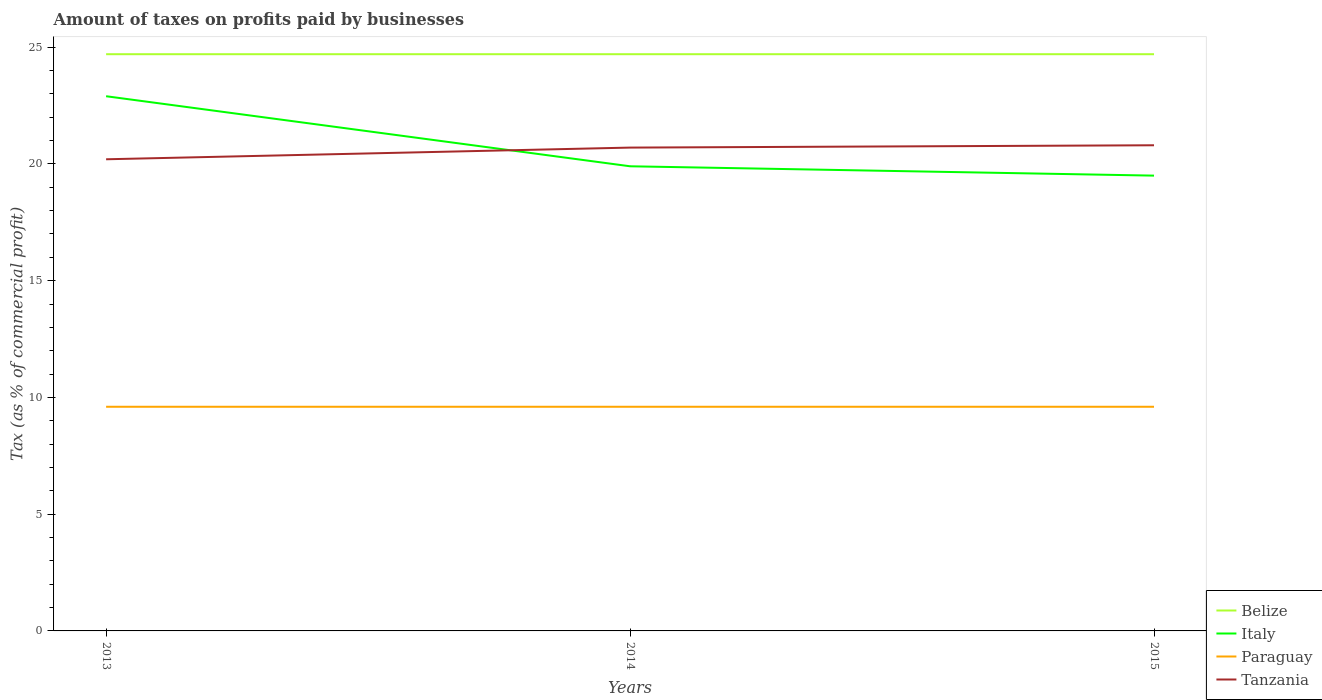How many different coloured lines are there?
Offer a terse response. 4. Is the number of lines equal to the number of legend labels?
Make the answer very short. Yes. Across all years, what is the maximum percentage of taxes paid by businesses in Italy?
Your answer should be very brief. 19.5. In which year was the percentage of taxes paid by businesses in Italy maximum?
Offer a terse response. 2015. How many lines are there?
Your response must be concise. 4. What is the difference between two consecutive major ticks on the Y-axis?
Your answer should be compact. 5. Are the values on the major ticks of Y-axis written in scientific E-notation?
Keep it short and to the point. No. Does the graph contain any zero values?
Ensure brevity in your answer.  No. How are the legend labels stacked?
Provide a short and direct response. Vertical. What is the title of the graph?
Keep it short and to the point. Amount of taxes on profits paid by businesses. Does "Guam" appear as one of the legend labels in the graph?
Make the answer very short. No. What is the label or title of the Y-axis?
Provide a short and direct response. Tax (as % of commercial profit). What is the Tax (as % of commercial profit) of Belize in 2013?
Provide a succinct answer. 24.7. What is the Tax (as % of commercial profit) in Italy in 2013?
Give a very brief answer. 22.9. What is the Tax (as % of commercial profit) of Paraguay in 2013?
Provide a short and direct response. 9.6. What is the Tax (as % of commercial profit) in Tanzania in 2013?
Ensure brevity in your answer.  20.2. What is the Tax (as % of commercial profit) of Belize in 2014?
Your answer should be very brief. 24.7. What is the Tax (as % of commercial profit) in Tanzania in 2014?
Offer a terse response. 20.7. What is the Tax (as % of commercial profit) of Belize in 2015?
Keep it short and to the point. 24.7. What is the Tax (as % of commercial profit) of Paraguay in 2015?
Your answer should be compact. 9.6. What is the Tax (as % of commercial profit) in Tanzania in 2015?
Ensure brevity in your answer.  20.8. Across all years, what is the maximum Tax (as % of commercial profit) in Belize?
Keep it short and to the point. 24.7. Across all years, what is the maximum Tax (as % of commercial profit) of Italy?
Make the answer very short. 22.9. Across all years, what is the maximum Tax (as % of commercial profit) in Tanzania?
Offer a terse response. 20.8. Across all years, what is the minimum Tax (as % of commercial profit) in Belize?
Make the answer very short. 24.7. Across all years, what is the minimum Tax (as % of commercial profit) in Italy?
Your response must be concise. 19.5. Across all years, what is the minimum Tax (as % of commercial profit) of Paraguay?
Your response must be concise. 9.6. Across all years, what is the minimum Tax (as % of commercial profit) in Tanzania?
Make the answer very short. 20.2. What is the total Tax (as % of commercial profit) in Belize in the graph?
Provide a short and direct response. 74.1. What is the total Tax (as % of commercial profit) in Italy in the graph?
Give a very brief answer. 62.3. What is the total Tax (as % of commercial profit) of Paraguay in the graph?
Your answer should be very brief. 28.8. What is the total Tax (as % of commercial profit) of Tanzania in the graph?
Ensure brevity in your answer.  61.7. What is the difference between the Tax (as % of commercial profit) of Belize in 2013 and that in 2014?
Your answer should be compact. 0. What is the difference between the Tax (as % of commercial profit) of Italy in 2013 and that in 2014?
Offer a terse response. 3. What is the difference between the Tax (as % of commercial profit) of Paraguay in 2013 and that in 2014?
Provide a succinct answer. 0. What is the difference between the Tax (as % of commercial profit) of Tanzania in 2013 and that in 2014?
Offer a terse response. -0.5. What is the difference between the Tax (as % of commercial profit) of Belize in 2013 and that in 2015?
Provide a succinct answer. 0. What is the difference between the Tax (as % of commercial profit) in Italy in 2014 and that in 2015?
Ensure brevity in your answer.  0.4. What is the difference between the Tax (as % of commercial profit) in Paraguay in 2014 and that in 2015?
Provide a short and direct response. 0. What is the difference between the Tax (as % of commercial profit) in Tanzania in 2014 and that in 2015?
Provide a succinct answer. -0.1. What is the difference between the Tax (as % of commercial profit) in Belize in 2013 and the Tax (as % of commercial profit) in Tanzania in 2014?
Offer a very short reply. 4. What is the difference between the Tax (as % of commercial profit) of Paraguay in 2013 and the Tax (as % of commercial profit) of Tanzania in 2014?
Ensure brevity in your answer.  -11.1. What is the difference between the Tax (as % of commercial profit) of Paraguay in 2013 and the Tax (as % of commercial profit) of Tanzania in 2015?
Offer a terse response. -11.2. What is the difference between the Tax (as % of commercial profit) of Belize in 2014 and the Tax (as % of commercial profit) of Paraguay in 2015?
Offer a terse response. 15.1. What is the difference between the Tax (as % of commercial profit) of Belize in 2014 and the Tax (as % of commercial profit) of Tanzania in 2015?
Your answer should be compact. 3.9. What is the difference between the Tax (as % of commercial profit) of Italy in 2014 and the Tax (as % of commercial profit) of Paraguay in 2015?
Provide a succinct answer. 10.3. What is the average Tax (as % of commercial profit) in Belize per year?
Your answer should be compact. 24.7. What is the average Tax (as % of commercial profit) in Italy per year?
Offer a terse response. 20.77. What is the average Tax (as % of commercial profit) of Tanzania per year?
Give a very brief answer. 20.57. In the year 2013, what is the difference between the Tax (as % of commercial profit) in Italy and Tax (as % of commercial profit) in Tanzania?
Your answer should be very brief. 2.7. In the year 2013, what is the difference between the Tax (as % of commercial profit) in Paraguay and Tax (as % of commercial profit) in Tanzania?
Your answer should be compact. -10.6. In the year 2014, what is the difference between the Tax (as % of commercial profit) in Belize and Tax (as % of commercial profit) in Paraguay?
Your response must be concise. 15.1. In the year 2014, what is the difference between the Tax (as % of commercial profit) in Italy and Tax (as % of commercial profit) in Paraguay?
Your answer should be very brief. 10.3. In the year 2014, what is the difference between the Tax (as % of commercial profit) of Italy and Tax (as % of commercial profit) of Tanzania?
Offer a terse response. -0.8. In the year 2014, what is the difference between the Tax (as % of commercial profit) of Paraguay and Tax (as % of commercial profit) of Tanzania?
Your response must be concise. -11.1. In the year 2015, what is the difference between the Tax (as % of commercial profit) in Belize and Tax (as % of commercial profit) in Paraguay?
Give a very brief answer. 15.1. In the year 2015, what is the difference between the Tax (as % of commercial profit) of Italy and Tax (as % of commercial profit) of Paraguay?
Keep it short and to the point. 9.9. What is the ratio of the Tax (as % of commercial profit) in Belize in 2013 to that in 2014?
Provide a short and direct response. 1. What is the ratio of the Tax (as % of commercial profit) in Italy in 2013 to that in 2014?
Ensure brevity in your answer.  1.15. What is the ratio of the Tax (as % of commercial profit) of Tanzania in 2013 to that in 2014?
Provide a succinct answer. 0.98. What is the ratio of the Tax (as % of commercial profit) in Italy in 2013 to that in 2015?
Your answer should be compact. 1.17. What is the ratio of the Tax (as % of commercial profit) of Tanzania in 2013 to that in 2015?
Provide a succinct answer. 0.97. What is the ratio of the Tax (as % of commercial profit) of Italy in 2014 to that in 2015?
Make the answer very short. 1.02. What is the difference between the highest and the second highest Tax (as % of commercial profit) in Belize?
Ensure brevity in your answer.  0. What is the difference between the highest and the second highest Tax (as % of commercial profit) in Paraguay?
Ensure brevity in your answer.  0. What is the difference between the highest and the lowest Tax (as % of commercial profit) of Belize?
Ensure brevity in your answer.  0. What is the difference between the highest and the lowest Tax (as % of commercial profit) of Tanzania?
Provide a short and direct response. 0.6. 